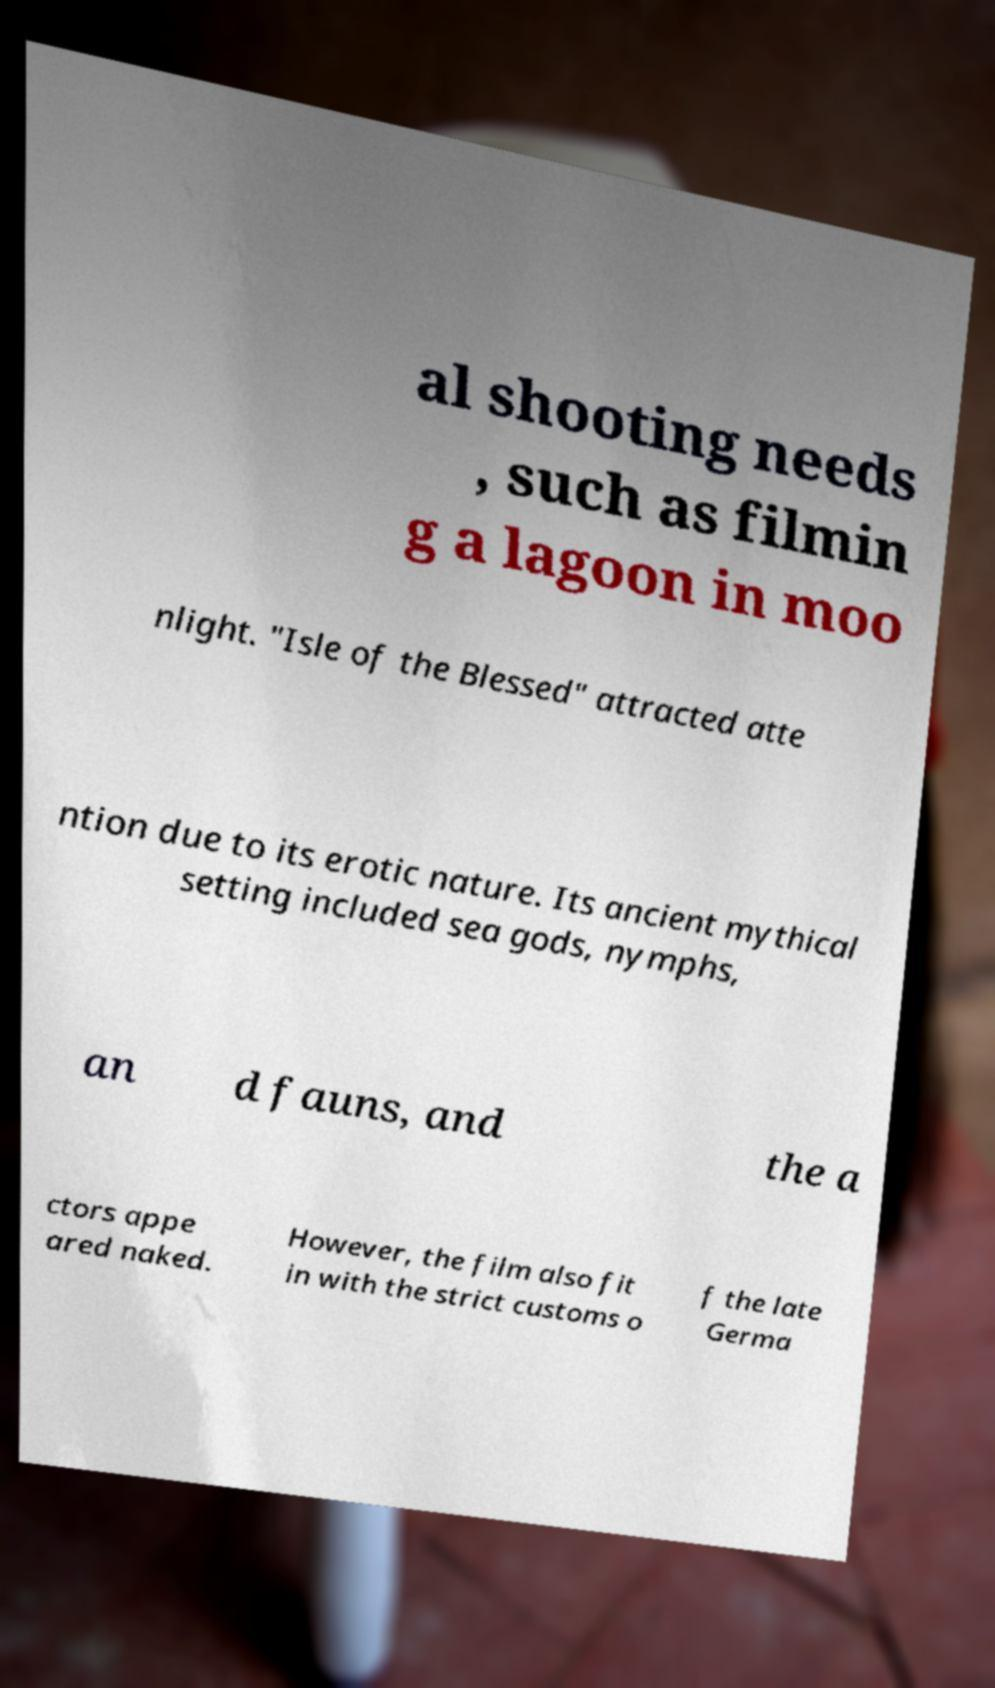Please identify and transcribe the text found in this image. al shooting needs , such as filmin g a lagoon in moo nlight. "Isle of the Blessed" attracted atte ntion due to its erotic nature. Its ancient mythical setting included sea gods, nymphs, an d fauns, and the a ctors appe ared naked. However, the film also fit in with the strict customs o f the late Germa 